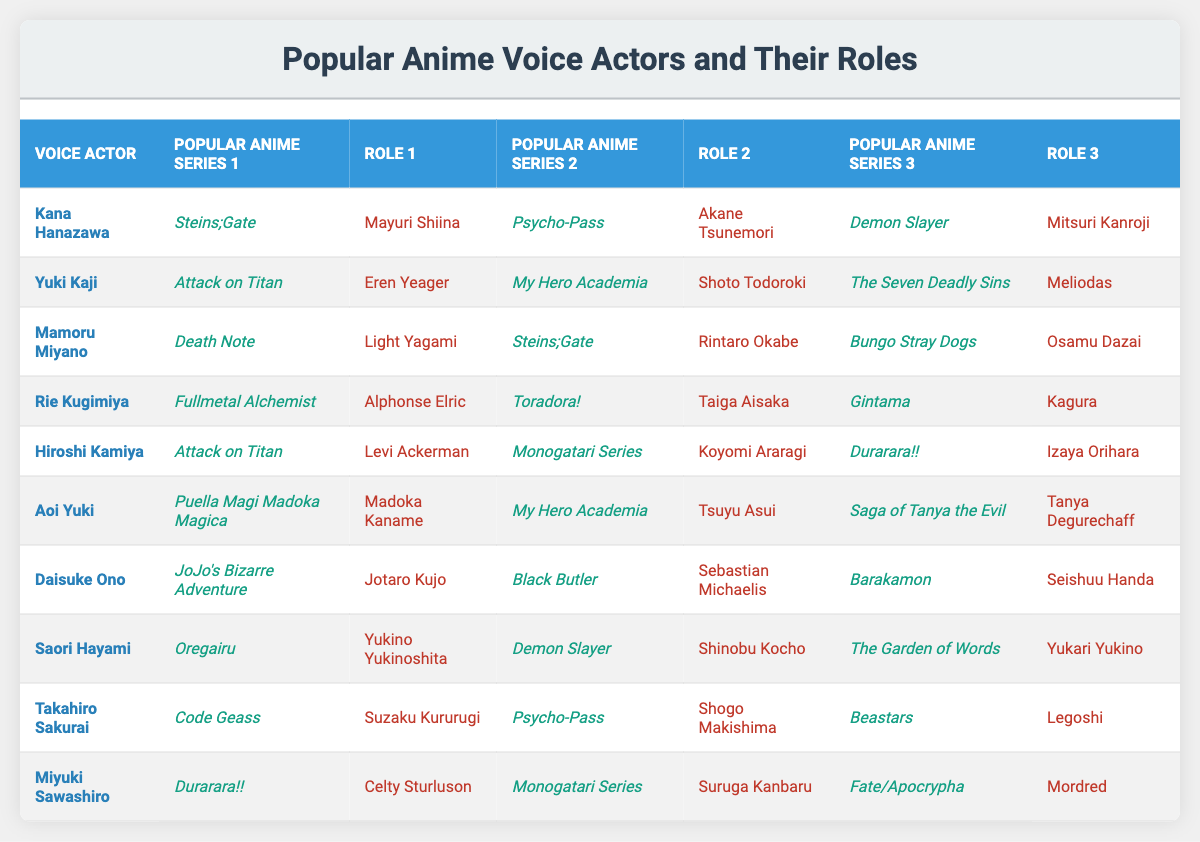What roles does Kana Hanazawa play in popular anime series? According to the table, Kana Hanazawa voices Mayuri Shiina in "Steins;Gate," Akane Tsunemori in "Psycho-Pass," and Mitsuri Kanroji in "Demon Slayer."
Answer: Mayuri Shiina, Akane Tsunemori, Mitsuri Kanroji Which voice actor has played the character Eren Yeager? The table shows that Yuki Kaji plays Eren Yeager in "Attack on Titan."
Answer: Yuki Kaji How many series does Mamoru Miyano have roles in according to the table? Mamoru Miyano is listed in three series: "Death Note," "Steins;Gate," and "Bungo Stray Dogs."
Answer: Three Is Rie Kugimiya known for playing any characters in "Gintama"? Yes, Rie Kugimiya plays Kagura in "Gintama."
Answer: Yes Which voice actor has the role of Shinobu Kocho, and in which series? Saori Hayami is the voice actor for Shinobu Kocho in "Demon Slayer."
Answer: Saori Hayami in "Demon Slayer" Among the listed voice actors, who has performed the most diverse range of roles? By analyzing the data, all actors have three roles each; therefore, there is no single actor with a more diverse range among the listed ones.
Answer: None, all have three roles Which character from "My Hero Academia" is voiced by Aoi Yuki? Aoi Yuki voices Tsuyu Asui in "My Hero Academia."
Answer: Tsuyu Asui Which series features both Levi Ackerman and Izaya Orihara, as mentioned in the table? The table indicates that "Attack on Titan" features Levi Ackerman and "Durarara!!" features Izaya Orihara, but they are not in the same series.
Answer: None What do the roles played by Takahiro Sakurai contribute to the overall demographic of characters in anime? Analyzing Sakurai's roles shows a mix of hero (Suzaku Kururugi), antagonist (Shogo Makishima), and complex characters (Legoshi), indicating he appeals to diverse audiences.
Answer: Diverse appeal If you were to list the characters voiced by Daisuke Ono, what would they be? Daisuke Ono voices Jotaro Kujo in "JoJo's Bizarre Adventure," Sebastian Michaelis in "Black Butler," and Seishuu Handa in "Barakamon."
Answer: Jotaro Kujo, Sebastian Michaelis, Seishuu Handa 